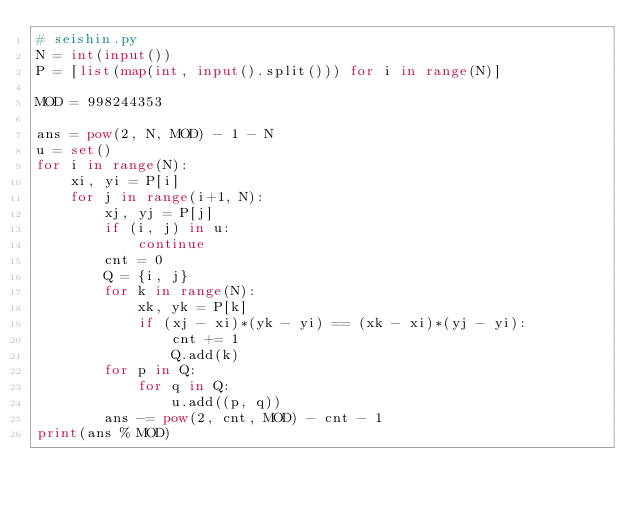Convert code to text. <code><loc_0><loc_0><loc_500><loc_500><_Python_># seishin.py
N = int(input())
P = [list(map(int, input().split())) for i in range(N)]

MOD = 998244353

ans = pow(2, N, MOD) - 1 - N
u = set()
for i in range(N):
    xi, yi = P[i]
    for j in range(i+1, N):
        xj, yj = P[j]
        if (i, j) in u:
            continue
        cnt = 0
        Q = {i, j}
        for k in range(N):
            xk, yk = P[k]
            if (xj - xi)*(yk - yi) == (xk - xi)*(yj - yi):
                cnt += 1
                Q.add(k)
        for p in Q:
            for q in Q:
                u.add((p, q))
        ans -= pow(2, cnt, MOD) - cnt - 1
print(ans % MOD)</code> 